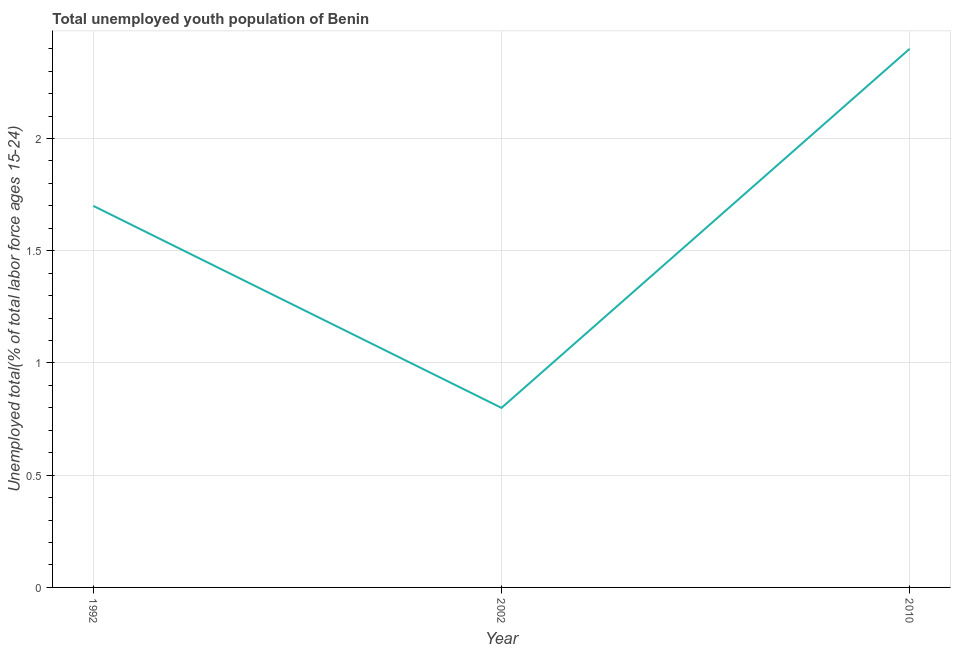What is the unemployed youth in 2002?
Give a very brief answer. 0.8. Across all years, what is the maximum unemployed youth?
Make the answer very short. 2.4. Across all years, what is the minimum unemployed youth?
Your response must be concise. 0.8. What is the sum of the unemployed youth?
Provide a short and direct response. 4.9. What is the difference between the unemployed youth in 1992 and 2002?
Your response must be concise. 0.9. What is the average unemployed youth per year?
Ensure brevity in your answer.  1.63. What is the median unemployed youth?
Make the answer very short. 1.7. What is the ratio of the unemployed youth in 1992 to that in 2002?
Keep it short and to the point. 2.13. What is the difference between the highest and the second highest unemployed youth?
Provide a short and direct response. 0.7. Is the sum of the unemployed youth in 1992 and 2002 greater than the maximum unemployed youth across all years?
Offer a terse response. Yes. What is the difference between the highest and the lowest unemployed youth?
Give a very brief answer. 1.6. Does the unemployed youth monotonically increase over the years?
Your answer should be very brief. No. How many lines are there?
Make the answer very short. 1. What is the difference between two consecutive major ticks on the Y-axis?
Ensure brevity in your answer.  0.5. Are the values on the major ticks of Y-axis written in scientific E-notation?
Give a very brief answer. No. Does the graph contain any zero values?
Offer a very short reply. No. What is the title of the graph?
Your response must be concise. Total unemployed youth population of Benin. What is the label or title of the X-axis?
Keep it short and to the point. Year. What is the label or title of the Y-axis?
Your response must be concise. Unemployed total(% of total labor force ages 15-24). What is the Unemployed total(% of total labor force ages 15-24) in 1992?
Your answer should be compact. 1.7. What is the Unemployed total(% of total labor force ages 15-24) of 2002?
Ensure brevity in your answer.  0.8. What is the Unemployed total(% of total labor force ages 15-24) of 2010?
Offer a very short reply. 2.4. What is the difference between the Unemployed total(% of total labor force ages 15-24) in 1992 and 2002?
Your answer should be very brief. 0.9. What is the difference between the Unemployed total(% of total labor force ages 15-24) in 1992 and 2010?
Offer a terse response. -0.7. What is the ratio of the Unemployed total(% of total labor force ages 15-24) in 1992 to that in 2002?
Ensure brevity in your answer.  2.12. What is the ratio of the Unemployed total(% of total labor force ages 15-24) in 1992 to that in 2010?
Offer a terse response. 0.71. What is the ratio of the Unemployed total(% of total labor force ages 15-24) in 2002 to that in 2010?
Keep it short and to the point. 0.33. 